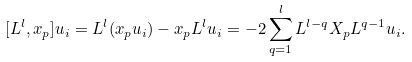Convert formula to latex. <formula><loc_0><loc_0><loc_500><loc_500>[ L ^ { l } , x _ { p } ] u _ { i } = L ^ { l } ( x _ { p } u _ { i } ) - x _ { p } L ^ { l } u _ { i } = - 2 \sum _ { q = 1 } ^ { l } L ^ { l - q } X _ { p } L ^ { q - 1 } u _ { i } .</formula> 